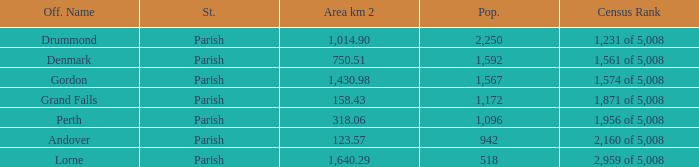Which parish has an area of 750.51? Denmark. 